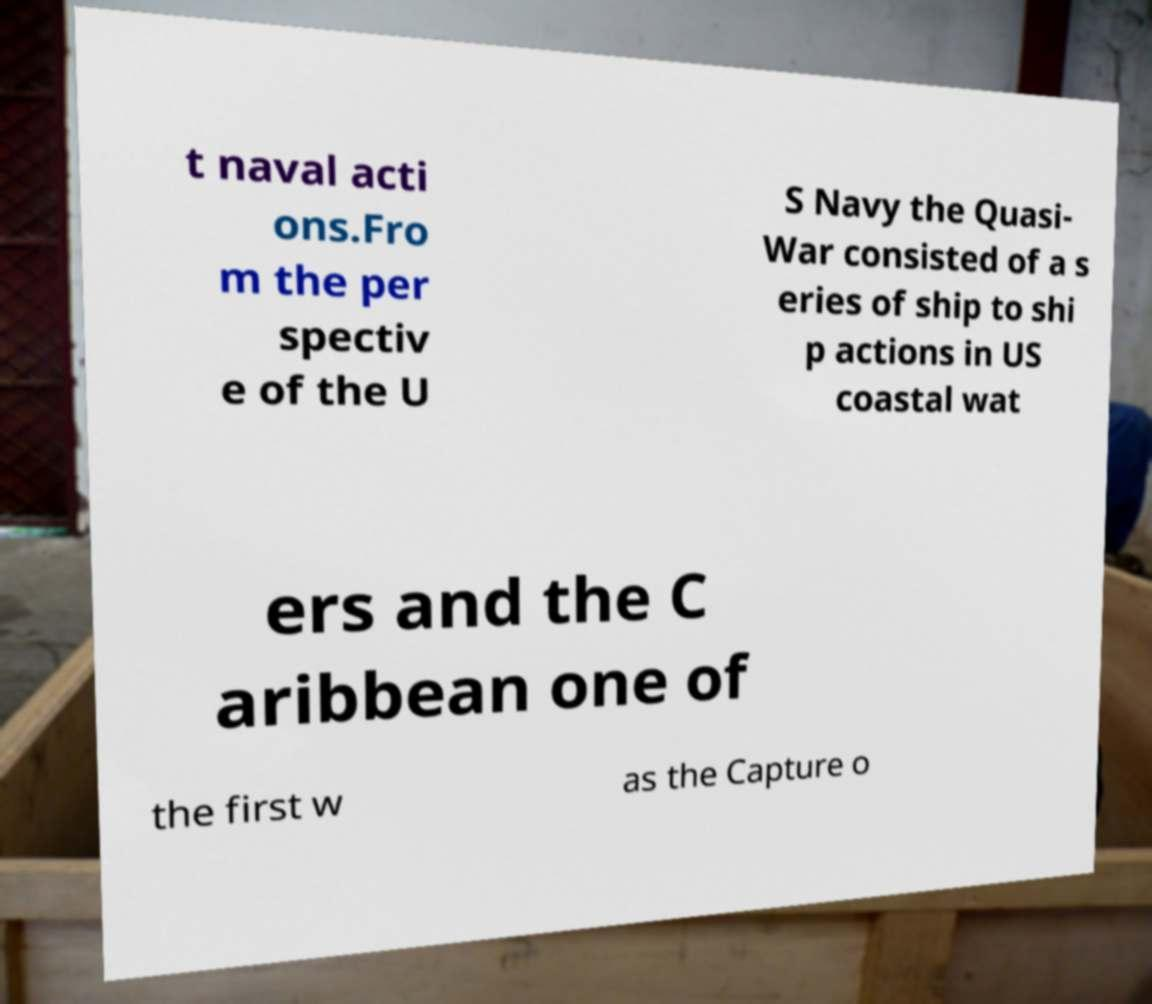Could you assist in decoding the text presented in this image and type it out clearly? t naval acti ons.Fro m the per spectiv e of the U S Navy the Quasi- War consisted of a s eries of ship to shi p actions in US coastal wat ers and the C aribbean one of the first w as the Capture o 